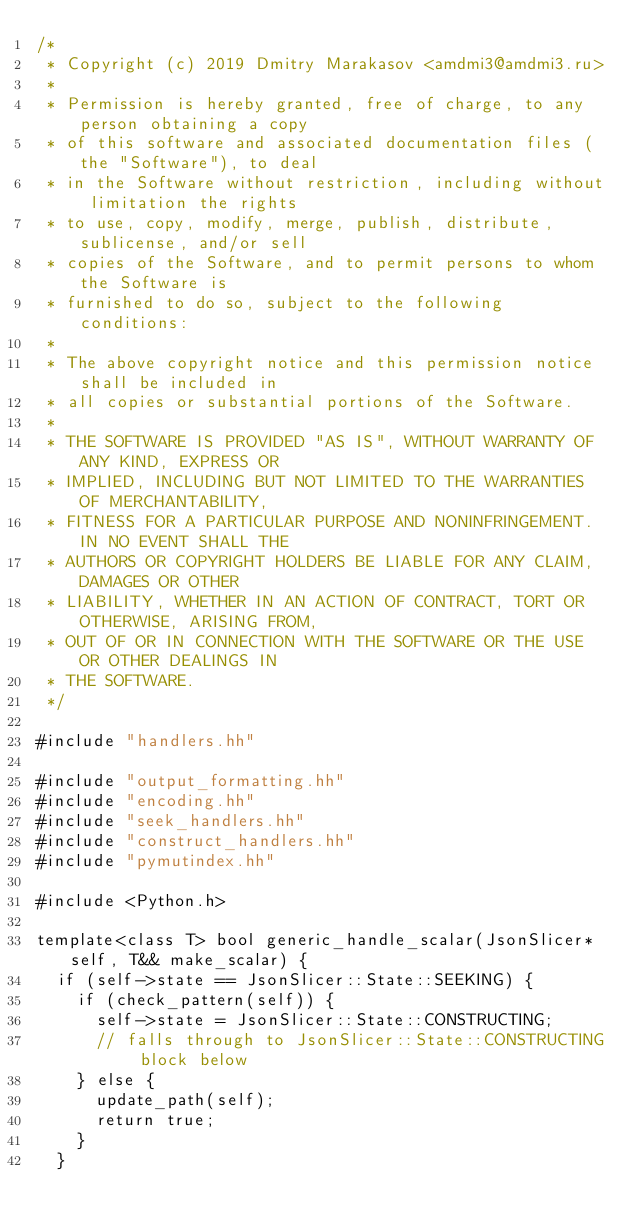<code> <loc_0><loc_0><loc_500><loc_500><_C++_>/*
 * Copyright (c) 2019 Dmitry Marakasov <amdmi3@amdmi3.ru>
 *
 * Permission is hereby granted, free of charge, to any person obtaining a copy
 * of this software and associated documentation files (the "Software"), to deal
 * in the Software without restriction, including without limitation the rights
 * to use, copy, modify, merge, publish, distribute, sublicense, and/or sell
 * copies of the Software, and to permit persons to whom the Software is
 * furnished to do so, subject to the following conditions:
 *
 * The above copyright notice and this permission notice shall be included in
 * all copies or substantial portions of the Software.
 *
 * THE SOFTWARE IS PROVIDED "AS IS", WITHOUT WARRANTY OF ANY KIND, EXPRESS OR
 * IMPLIED, INCLUDING BUT NOT LIMITED TO THE WARRANTIES OF MERCHANTABILITY,
 * FITNESS FOR A PARTICULAR PURPOSE AND NONINFRINGEMENT. IN NO EVENT SHALL THE
 * AUTHORS OR COPYRIGHT HOLDERS BE LIABLE FOR ANY CLAIM, DAMAGES OR OTHER
 * LIABILITY, WHETHER IN AN ACTION OF CONTRACT, TORT OR OTHERWISE, ARISING FROM,
 * OUT OF OR IN CONNECTION WITH THE SOFTWARE OR THE USE OR OTHER DEALINGS IN
 * THE SOFTWARE.
 */

#include "handlers.hh"

#include "output_formatting.hh"
#include "encoding.hh"
#include "seek_handlers.hh"
#include "construct_handlers.hh"
#include "pymutindex.hh"

#include <Python.h>

template<class T> bool generic_handle_scalar(JsonSlicer* self, T&& make_scalar) {
	if (self->state == JsonSlicer::State::SEEKING) {
		if (check_pattern(self)) {
			self->state = JsonSlicer::State::CONSTRUCTING;
			// falls through to JsonSlicer::State::CONSTRUCTING block below
		} else {
			update_path(self);
			return true;
		}
	}</code> 